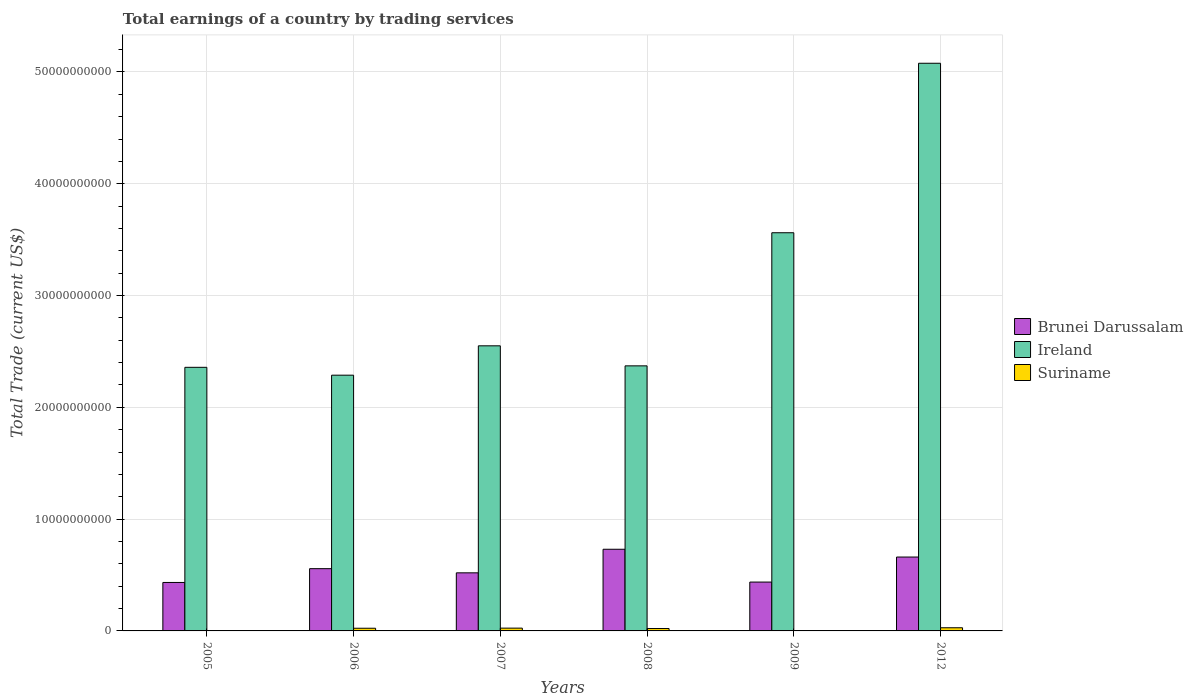How many groups of bars are there?
Make the answer very short. 6. Are the number of bars per tick equal to the number of legend labels?
Your response must be concise. No. Are the number of bars on each tick of the X-axis equal?
Offer a terse response. No. How many bars are there on the 6th tick from the left?
Provide a short and direct response. 3. How many bars are there on the 2nd tick from the right?
Offer a terse response. 3. What is the label of the 6th group of bars from the left?
Provide a short and direct response. 2012. What is the total earnings in Suriname in 2005?
Provide a succinct answer. 0. Across all years, what is the maximum total earnings in Ireland?
Your answer should be very brief. 5.08e+1. Across all years, what is the minimum total earnings in Brunei Darussalam?
Give a very brief answer. 4.34e+09. In which year was the total earnings in Suriname maximum?
Make the answer very short. 2012. What is the total total earnings in Suriname in the graph?
Provide a short and direct response. 9.98e+08. What is the difference between the total earnings in Ireland in 2006 and that in 2008?
Your answer should be compact. -8.33e+08. What is the difference between the total earnings in Ireland in 2009 and the total earnings in Brunei Darussalam in 2012?
Provide a succinct answer. 2.90e+1. What is the average total earnings in Ireland per year?
Provide a short and direct response. 3.03e+1. In the year 2008, what is the difference between the total earnings in Suriname and total earnings in Ireland?
Keep it short and to the point. -2.35e+1. In how many years, is the total earnings in Brunei Darussalam greater than 20000000000 US$?
Provide a succinct answer. 0. What is the ratio of the total earnings in Ireland in 2005 to that in 2006?
Your answer should be very brief. 1.03. Is the total earnings in Brunei Darussalam in 2006 less than that in 2008?
Your response must be concise. Yes. Is the difference between the total earnings in Suriname in 2006 and 2009 greater than the difference between the total earnings in Ireland in 2006 and 2009?
Offer a very short reply. Yes. What is the difference between the highest and the second highest total earnings in Brunei Darussalam?
Make the answer very short. 6.96e+08. What is the difference between the highest and the lowest total earnings in Suriname?
Offer a terse response. 2.83e+08. How many bars are there?
Your response must be concise. 17. Are all the bars in the graph horizontal?
Your answer should be very brief. No. What is the difference between two consecutive major ticks on the Y-axis?
Ensure brevity in your answer.  1.00e+1. Does the graph contain grids?
Make the answer very short. Yes. How are the legend labels stacked?
Offer a very short reply. Vertical. What is the title of the graph?
Offer a terse response. Total earnings of a country by trading services. Does "Georgia" appear as one of the legend labels in the graph?
Your answer should be very brief. No. What is the label or title of the X-axis?
Ensure brevity in your answer.  Years. What is the label or title of the Y-axis?
Your response must be concise. Total Trade (current US$). What is the Total Trade (current US$) of Brunei Darussalam in 2005?
Your response must be concise. 4.34e+09. What is the Total Trade (current US$) of Ireland in 2005?
Your answer should be compact. 2.36e+1. What is the Total Trade (current US$) of Brunei Darussalam in 2006?
Make the answer very short. 5.57e+09. What is the Total Trade (current US$) of Ireland in 2006?
Offer a very short reply. 2.29e+1. What is the Total Trade (current US$) of Suriname in 2006?
Give a very brief answer. 2.39e+08. What is the Total Trade (current US$) of Brunei Darussalam in 2007?
Your answer should be very brief. 5.20e+09. What is the Total Trade (current US$) of Ireland in 2007?
Offer a terse response. 2.55e+1. What is the Total Trade (current US$) of Suriname in 2007?
Provide a succinct answer. 2.50e+08. What is the Total Trade (current US$) in Brunei Darussalam in 2008?
Give a very brief answer. 7.30e+09. What is the Total Trade (current US$) of Ireland in 2008?
Offer a very short reply. 2.37e+1. What is the Total Trade (current US$) in Suriname in 2008?
Ensure brevity in your answer.  2.14e+08. What is the Total Trade (current US$) of Brunei Darussalam in 2009?
Keep it short and to the point. 4.37e+09. What is the Total Trade (current US$) of Ireland in 2009?
Make the answer very short. 3.56e+1. What is the Total Trade (current US$) in Suriname in 2009?
Your response must be concise. 1.25e+07. What is the Total Trade (current US$) of Brunei Darussalam in 2012?
Keep it short and to the point. 6.61e+09. What is the Total Trade (current US$) in Ireland in 2012?
Offer a very short reply. 5.08e+1. What is the Total Trade (current US$) in Suriname in 2012?
Your answer should be compact. 2.83e+08. Across all years, what is the maximum Total Trade (current US$) of Brunei Darussalam?
Your answer should be compact. 7.30e+09. Across all years, what is the maximum Total Trade (current US$) of Ireland?
Offer a terse response. 5.08e+1. Across all years, what is the maximum Total Trade (current US$) of Suriname?
Make the answer very short. 2.83e+08. Across all years, what is the minimum Total Trade (current US$) in Brunei Darussalam?
Make the answer very short. 4.34e+09. Across all years, what is the minimum Total Trade (current US$) of Ireland?
Give a very brief answer. 2.29e+1. What is the total Total Trade (current US$) in Brunei Darussalam in the graph?
Your answer should be compact. 3.34e+1. What is the total Total Trade (current US$) in Ireland in the graph?
Ensure brevity in your answer.  1.82e+11. What is the total Total Trade (current US$) in Suriname in the graph?
Provide a succinct answer. 9.98e+08. What is the difference between the Total Trade (current US$) in Brunei Darussalam in 2005 and that in 2006?
Your response must be concise. -1.23e+09. What is the difference between the Total Trade (current US$) in Ireland in 2005 and that in 2006?
Your answer should be very brief. 7.02e+08. What is the difference between the Total Trade (current US$) in Brunei Darussalam in 2005 and that in 2007?
Provide a short and direct response. -8.61e+08. What is the difference between the Total Trade (current US$) of Ireland in 2005 and that in 2007?
Your response must be concise. -1.92e+09. What is the difference between the Total Trade (current US$) of Brunei Darussalam in 2005 and that in 2008?
Provide a short and direct response. -2.97e+09. What is the difference between the Total Trade (current US$) of Ireland in 2005 and that in 2008?
Ensure brevity in your answer.  -1.31e+08. What is the difference between the Total Trade (current US$) in Brunei Darussalam in 2005 and that in 2009?
Give a very brief answer. -3.50e+07. What is the difference between the Total Trade (current US$) of Ireland in 2005 and that in 2009?
Your response must be concise. -1.20e+1. What is the difference between the Total Trade (current US$) in Brunei Darussalam in 2005 and that in 2012?
Your answer should be very brief. -2.27e+09. What is the difference between the Total Trade (current US$) in Ireland in 2005 and that in 2012?
Ensure brevity in your answer.  -2.72e+1. What is the difference between the Total Trade (current US$) in Brunei Darussalam in 2006 and that in 2007?
Keep it short and to the point. 3.73e+08. What is the difference between the Total Trade (current US$) in Ireland in 2006 and that in 2007?
Provide a short and direct response. -2.63e+09. What is the difference between the Total Trade (current US$) of Suriname in 2006 and that in 2007?
Provide a short and direct response. -1.05e+07. What is the difference between the Total Trade (current US$) of Brunei Darussalam in 2006 and that in 2008?
Your answer should be very brief. -1.74e+09. What is the difference between the Total Trade (current US$) in Ireland in 2006 and that in 2008?
Your answer should be compact. -8.33e+08. What is the difference between the Total Trade (current US$) in Suriname in 2006 and that in 2008?
Provide a short and direct response. 2.54e+07. What is the difference between the Total Trade (current US$) of Brunei Darussalam in 2006 and that in 2009?
Keep it short and to the point. 1.20e+09. What is the difference between the Total Trade (current US$) of Ireland in 2006 and that in 2009?
Provide a short and direct response. -1.27e+1. What is the difference between the Total Trade (current US$) in Suriname in 2006 and that in 2009?
Ensure brevity in your answer.  2.27e+08. What is the difference between the Total Trade (current US$) in Brunei Darussalam in 2006 and that in 2012?
Give a very brief answer. -1.04e+09. What is the difference between the Total Trade (current US$) of Ireland in 2006 and that in 2012?
Provide a succinct answer. -2.79e+1. What is the difference between the Total Trade (current US$) of Suriname in 2006 and that in 2012?
Offer a very short reply. -4.34e+07. What is the difference between the Total Trade (current US$) of Brunei Darussalam in 2007 and that in 2008?
Your answer should be very brief. -2.11e+09. What is the difference between the Total Trade (current US$) of Ireland in 2007 and that in 2008?
Ensure brevity in your answer.  1.79e+09. What is the difference between the Total Trade (current US$) of Suriname in 2007 and that in 2008?
Ensure brevity in your answer.  3.59e+07. What is the difference between the Total Trade (current US$) in Brunei Darussalam in 2007 and that in 2009?
Provide a succinct answer. 8.26e+08. What is the difference between the Total Trade (current US$) in Ireland in 2007 and that in 2009?
Give a very brief answer. -1.01e+1. What is the difference between the Total Trade (current US$) of Suriname in 2007 and that in 2009?
Offer a very short reply. 2.37e+08. What is the difference between the Total Trade (current US$) of Brunei Darussalam in 2007 and that in 2012?
Give a very brief answer. -1.41e+09. What is the difference between the Total Trade (current US$) in Ireland in 2007 and that in 2012?
Ensure brevity in your answer.  -2.53e+1. What is the difference between the Total Trade (current US$) of Suriname in 2007 and that in 2012?
Ensure brevity in your answer.  -3.29e+07. What is the difference between the Total Trade (current US$) of Brunei Darussalam in 2008 and that in 2009?
Your response must be concise. 2.93e+09. What is the difference between the Total Trade (current US$) in Ireland in 2008 and that in 2009?
Provide a succinct answer. -1.19e+1. What is the difference between the Total Trade (current US$) of Suriname in 2008 and that in 2009?
Give a very brief answer. 2.01e+08. What is the difference between the Total Trade (current US$) of Brunei Darussalam in 2008 and that in 2012?
Provide a succinct answer. 6.96e+08. What is the difference between the Total Trade (current US$) in Ireland in 2008 and that in 2012?
Your response must be concise. -2.71e+1. What is the difference between the Total Trade (current US$) in Suriname in 2008 and that in 2012?
Your response must be concise. -6.88e+07. What is the difference between the Total Trade (current US$) in Brunei Darussalam in 2009 and that in 2012?
Offer a very short reply. -2.24e+09. What is the difference between the Total Trade (current US$) in Ireland in 2009 and that in 2012?
Give a very brief answer. -1.52e+1. What is the difference between the Total Trade (current US$) of Suriname in 2009 and that in 2012?
Make the answer very short. -2.70e+08. What is the difference between the Total Trade (current US$) of Brunei Darussalam in 2005 and the Total Trade (current US$) of Ireland in 2006?
Ensure brevity in your answer.  -1.85e+1. What is the difference between the Total Trade (current US$) in Brunei Darussalam in 2005 and the Total Trade (current US$) in Suriname in 2006?
Keep it short and to the point. 4.10e+09. What is the difference between the Total Trade (current US$) in Ireland in 2005 and the Total Trade (current US$) in Suriname in 2006?
Your answer should be very brief. 2.33e+1. What is the difference between the Total Trade (current US$) in Brunei Darussalam in 2005 and the Total Trade (current US$) in Ireland in 2007?
Your answer should be very brief. -2.12e+1. What is the difference between the Total Trade (current US$) in Brunei Darussalam in 2005 and the Total Trade (current US$) in Suriname in 2007?
Provide a succinct answer. 4.09e+09. What is the difference between the Total Trade (current US$) of Ireland in 2005 and the Total Trade (current US$) of Suriname in 2007?
Offer a very short reply. 2.33e+1. What is the difference between the Total Trade (current US$) of Brunei Darussalam in 2005 and the Total Trade (current US$) of Ireland in 2008?
Ensure brevity in your answer.  -1.94e+1. What is the difference between the Total Trade (current US$) in Brunei Darussalam in 2005 and the Total Trade (current US$) in Suriname in 2008?
Your response must be concise. 4.12e+09. What is the difference between the Total Trade (current US$) of Ireland in 2005 and the Total Trade (current US$) of Suriname in 2008?
Offer a terse response. 2.34e+1. What is the difference between the Total Trade (current US$) of Brunei Darussalam in 2005 and the Total Trade (current US$) of Ireland in 2009?
Ensure brevity in your answer.  -3.13e+1. What is the difference between the Total Trade (current US$) of Brunei Darussalam in 2005 and the Total Trade (current US$) of Suriname in 2009?
Provide a succinct answer. 4.32e+09. What is the difference between the Total Trade (current US$) in Ireland in 2005 and the Total Trade (current US$) in Suriname in 2009?
Provide a succinct answer. 2.36e+1. What is the difference between the Total Trade (current US$) of Brunei Darussalam in 2005 and the Total Trade (current US$) of Ireland in 2012?
Provide a short and direct response. -4.64e+1. What is the difference between the Total Trade (current US$) in Brunei Darussalam in 2005 and the Total Trade (current US$) in Suriname in 2012?
Ensure brevity in your answer.  4.05e+09. What is the difference between the Total Trade (current US$) in Ireland in 2005 and the Total Trade (current US$) in Suriname in 2012?
Offer a terse response. 2.33e+1. What is the difference between the Total Trade (current US$) of Brunei Darussalam in 2006 and the Total Trade (current US$) of Ireland in 2007?
Ensure brevity in your answer.  -1.99e+1. What is the difference between the Total Trade (current US$) of Brunei Darussalam in 2006 and the Total Trade (current US$) of Suriname in 2007?
Your answer should be compact. 5.32e+09. What is the difference between the Total Trade (current US$) of Ireland in 2006 and the Total Trade (current US$) of Suriname in 2007?
Your response must be concise. 2.26e+1. What is the difference between the Total Trade (current US$) of Brunei Darussalam in 2006 and the Total Trade (current US$) of Ireland in 2008?
Offer a very short reply. -1.81e+1. What is the difference between the Total Trade (current US$) in Brunei Darussalam in 2006 and the Total Trade (current US$) in Suriname in 2008?
Your answer should be compact. 5.36e+09. What is the difference between the Total Trade (current US$) of Ireland in 2006 and the Total Trade (current US$) of Suriname in 2008?
Make the answer very short. 2.27e+1. What is the difference between the Total Trade (current US$) of Brunei Darussalam in 2006 and the Total Trade (current US$) of Ireland in 2009?
Your response must be concise. -3.00e+1. What is the difference between the Total Trade (current US$) in Brunei Darussalam in 2006 and the Total Trade (current US$) in Suriname in 2009?
Offer a terse response. 5.56e+09. What is the difference between the Total Trade (current US$) of Ireland in 2006 and the Total Trade (current US$) of Suriname in 2009?
Offer a terse response. 2.29e+1. What is the difference between the Total Trade (current US$) of Brunei Darussalam in 2006 and the Total Trade (current US$) of Ireland in 2012?
Keep it short and to the point. -4.52e+1. What is the difference between the Total Trade (current US$) in Brunei Darussalam in 2006 and the Total Trade (current US$) in Suriname in 2012?
Keep it short and to the point. 5.29e+09. What is the difference between the Total Trade (current US$) of Ireland in 2006 and the Total Trade (current US$) of Suriname in 2012?
Ensure brevity in your answer.  2.26e+1. What is the difference between the Total Trade (current US$) of Brunei Darussalam in 2007 and the Total Trade (current US$) of Ireland in 2008?
Your answer should be very brief. -1.85e+1. What is the difference between the Total Trade (current US$) of Brunei Darussalam in 2007 and the Total Trade (current US$) of Suriname in 2008?
Ensure brevity in your answer.  4.98e+09. What is the difference between the Total Trade (current US$) of Ireland in 2007 and the Total Trade (current US$) of Suriname in 2008?
Your answer should be compact. 2.53e+1. What is the difference between the Total Trade (current US$) of Brunei Darussalam in 2007 and the Total Trade (current US$) of Ireland in 2009?
Offer a very short reply. -3.04e+1. What is the difference between the Total Trade (current US$) in Brunei Darussalam in 2007 and the Total Trade (current US$) in Suriname in 2009?
Offer a very short reply. 5.18e+09. What is the difference between the Total Trade (current US$) of Ireland in 2007 and the Total Trade (current US$) of Suriname in 2009?
Provide a short and direct response. 2.55e+1. What is the difference between the Total Trade (current US$) of Brunei Darussalam in 2007 and the Total Trade (current US$) of Ireland in 2012?
Make the answer very short. -4.56e+1. What is the difference between the Total Trade (current US$) of Brunei Darussalam in 2007 and the Total Trade (current US$) of Suriname in 2012?
Keep it short and to the point. 4.91e+09. What is the difference between the Total Trade (current US$) in Ireland in 2007 and the Total Trade (current US$) in Suriname in 2012?
Provide a short and direct response. 2.52e+1. What is the difference between the Total Trade (current US$) of Brunei Darussalam in 2008 and the Total Trade (current US$) of Ireland in 2009?
Provide a succinct answer. -2.83e+1. What is the difference between the Total Trade (current US$) of Brunei Darussalam in 2008 and the Total Trade (current US$) of Suriname in 2009?
Your response must be concise. 7.29e+09. What is the difference between the Total Trade (current US$) of Ireland in 2008 and the Total Trade (current US$) of Suriname in 2009?
Provide a short and direct response. 2.37e+1. What is the difference between the Total Trade (current US$) in Brunei Darussalam in 2008 and the Total Trade (current US$) in Ireland in 2012?
Offer a terse response. -4.35e+1. What is the difference between the Total Trade (current US$) of Brunei Darussalam in 2008 and the Total Trade (current US$) of Suriname in 2012?
Provide a succinct answer. 7.02e+09. What is the difference between the Total Trade (current US$) in Ireland in 2008 and the Total Trade (current US$) in Suriname in 2012?
Provide a short and direct response. 2.34e+1. What is the difference between the Total Trade (current US$) of Brunei Darussalam in 2009 and the Total Trade (current US$) of Ireland in 2012?
Ensure brevity in your answer.  -4.64e+1. What is the difference between the Total Trade (current US$) of Brunei Darussalam in 2009 and the Total Trade (current US$) of Suriname in 2012?
Provide a short and direct response. 4.09e+09. What is the difference between the Total Trade (current US$) in Ireland in 2009 and the Total Trade (current US$) in Suriname in 2012?
Your answer should be compact. 3.53e+1. What is the average Total Trade (current US$) in Brunei Darussalam per year?
Ensure brevity in your answer.  5.56e+09. What is the average Total Trade (current US$) of Ireland per year?
Keep it short and to the point. 3.03e+1. What is the average Total Trade (current US$) of Suriname per year?
Your answer should be compact. 1.66e+08. In the year 2005, what is the difference between the Total Trade (current US$) of Brunei Darussalam and Total Trade (current US$) of Ireland?
Offer a very short reply. -1.92e+1. In the year 2006, what is the difference between the Total Trade (current US$) of Brunei Darussalam and Total Trade (current US$) of Ireland?
Provide a succinct answer. -1.73e+1. In the year 2006, what is the difference between the Total Trade (current US$) in Brunei Darussalam and Total Trade (current US$) in Suriname?
Keep it short and to the point. 5.33e+09. In the year 2006, what is the difference between the Total Trade (current US$) of Ireland and Total Trade (current US$) of Suriname?
Ensure brevity in your answer.  2.26e+1. In the year 2007, what is the difference between the Total Trade (current US$) of Brunei Darussalam and Total Trade (current US$) of Ireland?
Make the answer very short. -2.03e+1. In the year 2007, what is the difference between the Total Trade (current US$) in Brunei Darussalam and Total Trade (current US$) in Suriname?
Your response must be concise. 4.95e+09. In the year 2007, what is the difference between the Total Trade (current US$) of Ireland and Total Trade (current US$) of Suriname?
Your answer should be very brief. 2.53e+1. In the year 2008, what is the difference between the Total Trade (current US$) in Brunei Darussalam and Total Trade (current US$) in Ireland?
Make the answer very short. -1.64e+1. In the year 2008, what is the difference between the Total Trade (current US$) in Brunei Darussalam and Total Trade (current US$) in Suriname?
Offer a very short reply. 7.09e+09. In the year 2008, what is the difference between the Total Trade (current US$) of Ireland and Total Trade (current US$) of Suriname?
Your answer should be very brief. 2.35e+1. In the year 2009, what is the difference between the Total Trade (current US$) of Brunei Darussalam and Total Trade (current US$) of Ireland?
Keep it short and to the point. -3.12e+1. In the year 2009, what is the difference between the Total Trade (current US$) of Brunei Darussalam and Total Trade (current US$) of Suriname?
Your response must be concise. 4.36e+09. In the year 2009, what is the difference between the Total Trade (current US$) of Ireland and Total Trade (current US$) of Suriname?
Your answer should be compact. 3.56e+1. In the year 2012, what is the difference between the Total Trade (current US$) of Brunei Darussalam and Total Trade (current US$) of Ireland?
Your answer should be very brief. -4.42e+1. In the year 2012, what is the difference between the Total Trade (current US$) of Brunei Darussalam and Total Trade (current US$) of Suriname?
Offer a terse response. 6.33e+09. In the year 2012, what is the difference between the Total Trade (current US$) of Ireland and Total Trade (current US$) of Suriname?
Provide a succinct answer. 5.05e+1. What is the ratio of the Total Trade (current US$) of Brunei Darussalam in 2005 to that in 2006?
Your answer should be compact. 0.78. What is the ratio of the Total Trade (current US$) of Ireland in 2005 to that in 2006?
Keep it short and to the point. 1.03. What is the ratio of the Total Trade (current US$) of Brunei Darussalam in 2005 to that in 2007?
Your answer should be compact. 0.83. What is the ratio of the Total Trade (current US$) in Ireland in 2005 to that in 2007?
Your response must be concise. 0.92. What is the ratio of the Total Trade (current US$) of Brunei Darussalam in 2005 to that in 2008?
Offer a very short reply. 0.59. What is the ratio of the Total Trade (current US$) in Brunei Darussalam in 2005 to that in 2009?
Give a very brief answer. 0.99. What is the ratio of the Total Trade (current US$) of Ireland in 2005 to that in 2009?
Provide a short and direct response. 0.66. What is the ratio of the Total Trade (current US$) in Brunei Darussalam in 2005 to that in 2012?
Give a very brief answer. 0.66. What is the ratio of the Total Trade (current US$) in Ireland in 2005 to that in 2012?
Your response must be concise. 0.46. What is the ratio of the Total Trade (current US$) of Brunei Darussalam in 2006 to that in 2007?
Make the answer very short. 1.07. What is the ratio of the Total Trade (current US$) in Ireland in 2006 to that in 2007?
Ensure brevity in your answer.  0.9. What is the ratio of the Total Trade (current US$) in Suriname in 2006 to that in 2007?
Your answer should be compact. 0.96. What is the ratio of the Total Trade (current US$) of Brunei Darussalam in 2006 to that in 2008?
Give a very brief answer. 0.76. What is the ratio of the Total Trade (current US$) in Ireland in 2006 to that in 2008?
Your response must be concise. 0.96. What is the ratio of the Total Trade (current US$) of Suriname in 2006 to that in 2008?
Your answer should be compact. 1.12. What is the ratio of the Total Trade (current US$) of Brunei Darussalam in 2006 to that in 2009?
Provide a short and direct response. 1.27. What is the ratio of the Total Trade (current US$) of Ireland in 2006 to that in 2009?
Offer a very short reply. 0.64. What is the ratio of the Total Trade (current US$) in Suriname in 2006 to that in 2009?
Your answer should be compact. 19.14. What is the ratio of the Total Trade (current US$) in Brunei Darussalam in 2006 to that in 2012?
Provide a succinct answer. 0.84. What is the ratio of the Total Trade (current US$) in Ireland in 2006 to that in 2012?
Make the answer very short. 0.45. What is the ratio of the Total Trade (current US$) in Suriname in 2006 to that in 2012?
Keep it short and to the point. 0.85. What is the ratio of the Total Trade (current US$) in Brunei Darussalam in 2007 to that in 2008?
Offer a very short reply. 0.71. What is the ratio of the Total Trade (current US$) in Ireland in 2007 to that in 2008?
Make the answer very short. 1.08. What is the ratio of the Total Trade (current US$) of Suriname in 2007 to that in 2008?
Make the answer very short. 1.17. What is the ratio of the Total Trade (current US$) of Brunei Darussalam in 2007 to that in 2009?
Ensure brevity in your answer.  1.19. What is the ratio of the Total Trade (current US$) of Ireland in 2007 to that in 2009?
Offer a terse response. 0.72. What is the ratio of the Total Trade (current US$) of Suriname in 2007 to that in 2009?
Give a very brief answer. 19.98. What is the ratio of the Total Trade (current US$) of Brunei Darussalam in 2007 to that in 2012?
Provide a succinct answer. 0.79. What is the ratio of the Total Trade (current US$) in Ireland in 2007 to that in 2012?
Keep it short and to the point. 0.5. What is the ratio of the Total Trade (current US$) of Suriname in 2007 to that in 2012?
Offer a very short reply. 0.88. What is the ratio of the Total Trade (current US$) in Brunei Darussalam in 2008 to that in 2009?
Offer a terse response. 1.67. What is the ratio of the Total Trade (current US$) of Ireland in 2008 to that in 2009?
Offer a terse response. 0.67. What is the ratio of the Total Trade (current US$) of Suriname in 2008 to that in 2009?
Keep it short and to the point. 17.1. What is the ratio of the Total Trade (current US$) of Brunei Darussalam in 2008 to that in 2012?
Provide a short and direct response. 1.11. What is the ratio of the Total Trade (current US$) of Ireland in 2008 to that in 2012?
Your answer should be very brief. 0.47. What is the ratio of the Total Trade (current US$) in Suriname in 2008 to that in 2012?
Offer a very short reply. 0.76. What is the ratio of the Total Trade (current US$) of Brunei Darussalam in 2009 to that in 2012?
Keep it short and to the point. 0.66. What is the ratio of the Total Trade (current US$) in Ireland in 2009 to that in 2012?
Give a very brief answer. 0.7. What is the ratio of the Total Trade (current US$) in Suriname in 2009 to that in 2012?
Make the answer very short. 0.04. What is the difference between the highest and the second highest Total Trade (current US$) in Brunei Darussalam?
Give a very brief answer. 6.96e+08. What is the difference between the highest and the second highest Total Trade (current US$) of Ireland?
Your answer should be compact. 1.52e+1. What is the difference between the highest and the second highest Total Trade (current US$) of Suriname?
Offer a very short reply. 3.29e+07. What is the difference between the highest and the lowest Total Trade (current US$) of Brunei Darussalam?
Ensure brevity in your answer.  2.97e+09. What is the difference between the highest and the lowest Total Trade (current US$) of Ireland?
Ensure brevity in your answer.  2.79e+1. What is the difference between the highest and the lowest Total Trade (current US$) of Suriname?
Offer a very short reply. 2.83e+08. 